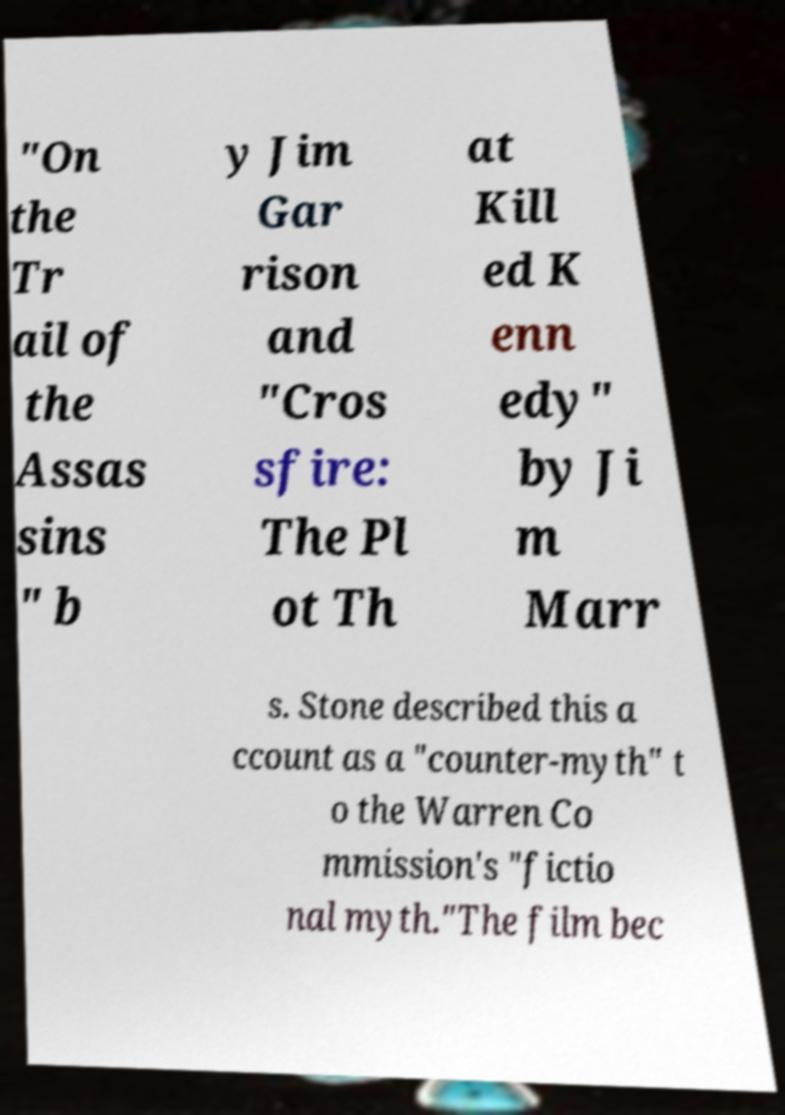Could you extract and type out the text from this image? "On the Tr ail of the Assas sins " b y Jim Gar rison and "Cros sfire: The Pl ot Th at Kill ed K enn edy" by Ji m Marr s. Stone described this a ccount as a "counter-myth" t o the Warren Co mmission's "fictio nal myth."The film bec 